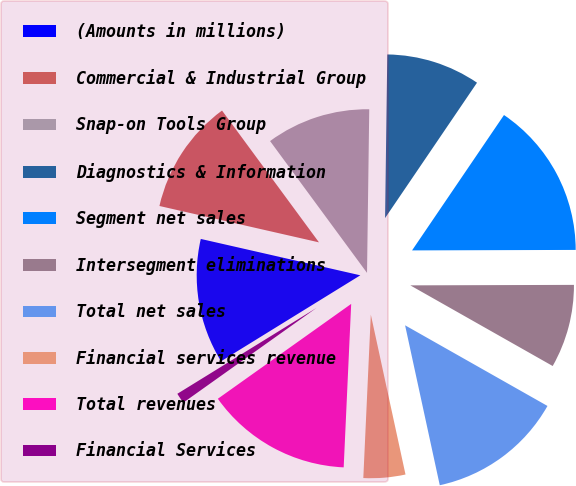Convert chart. <chart><loc_0><loc_0><loc_500><loc_500><pie_chart><fcel>(Amounts in millions)<fcel>Commercial & Industrial Group<fcel>Snap-on Tools Group<fcel>Diagnostics & Information<fcel>Segment net sales<fcel>Intersegment eliminations<fcel>Total net sales<fcel>Financial services revenue<fcel>Total revenues<fcel>Financial Services<nl><fcel>12.37%<fcel>11.34%<fcel>10.31%<fcel>9.28%<fcel>15.46%<fcel>8.25%<fcel>13.4%<fcel>4.13%<fcel>14.43%<fcel>1.04%<nl></chart> 